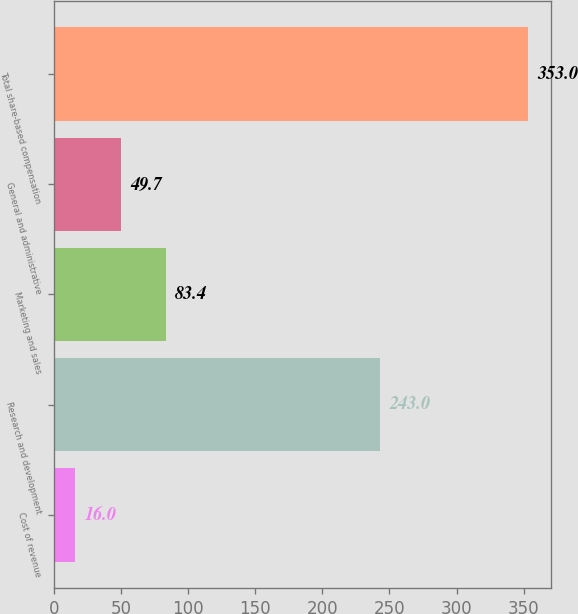<chart> <loc_0><loc_0><loc_500><loc_500><bar_chart><fcel>Cost of revenue<fcel>Research and development<fcel>Marketing and sales<fcel>General and administrative<fcel>Total share-based compensation<nl><fcel>16<fcel>243<fcel>83.4<fcel>49.7<fcel>353<nl></chart> 